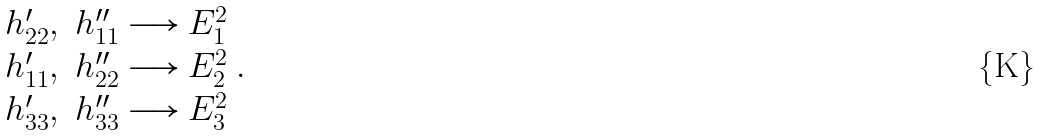<formula> <loc_0><loc_0><loc_500><loc_500>\begin{array} { c } h _ { 2 2 } ^ { \prime } , \ h _ { 1 1 } ^ { \prime \prime } \longrightarrow E _ { 1 } ^ { 2 } \\ h _ { 1 1 } ^ { \prime } , \ h _ { 2 2 } ^ { \prime \prime } \longrightarrow E _ { 2 } ^ { 2 } \\ h _ { 3 3 } ^ { \prime } , \ h _ { 3 3 } ^ { \prime \prime } \longrightarrow E _ { 3 } ^ { 2 } \end{array} .</formula> 